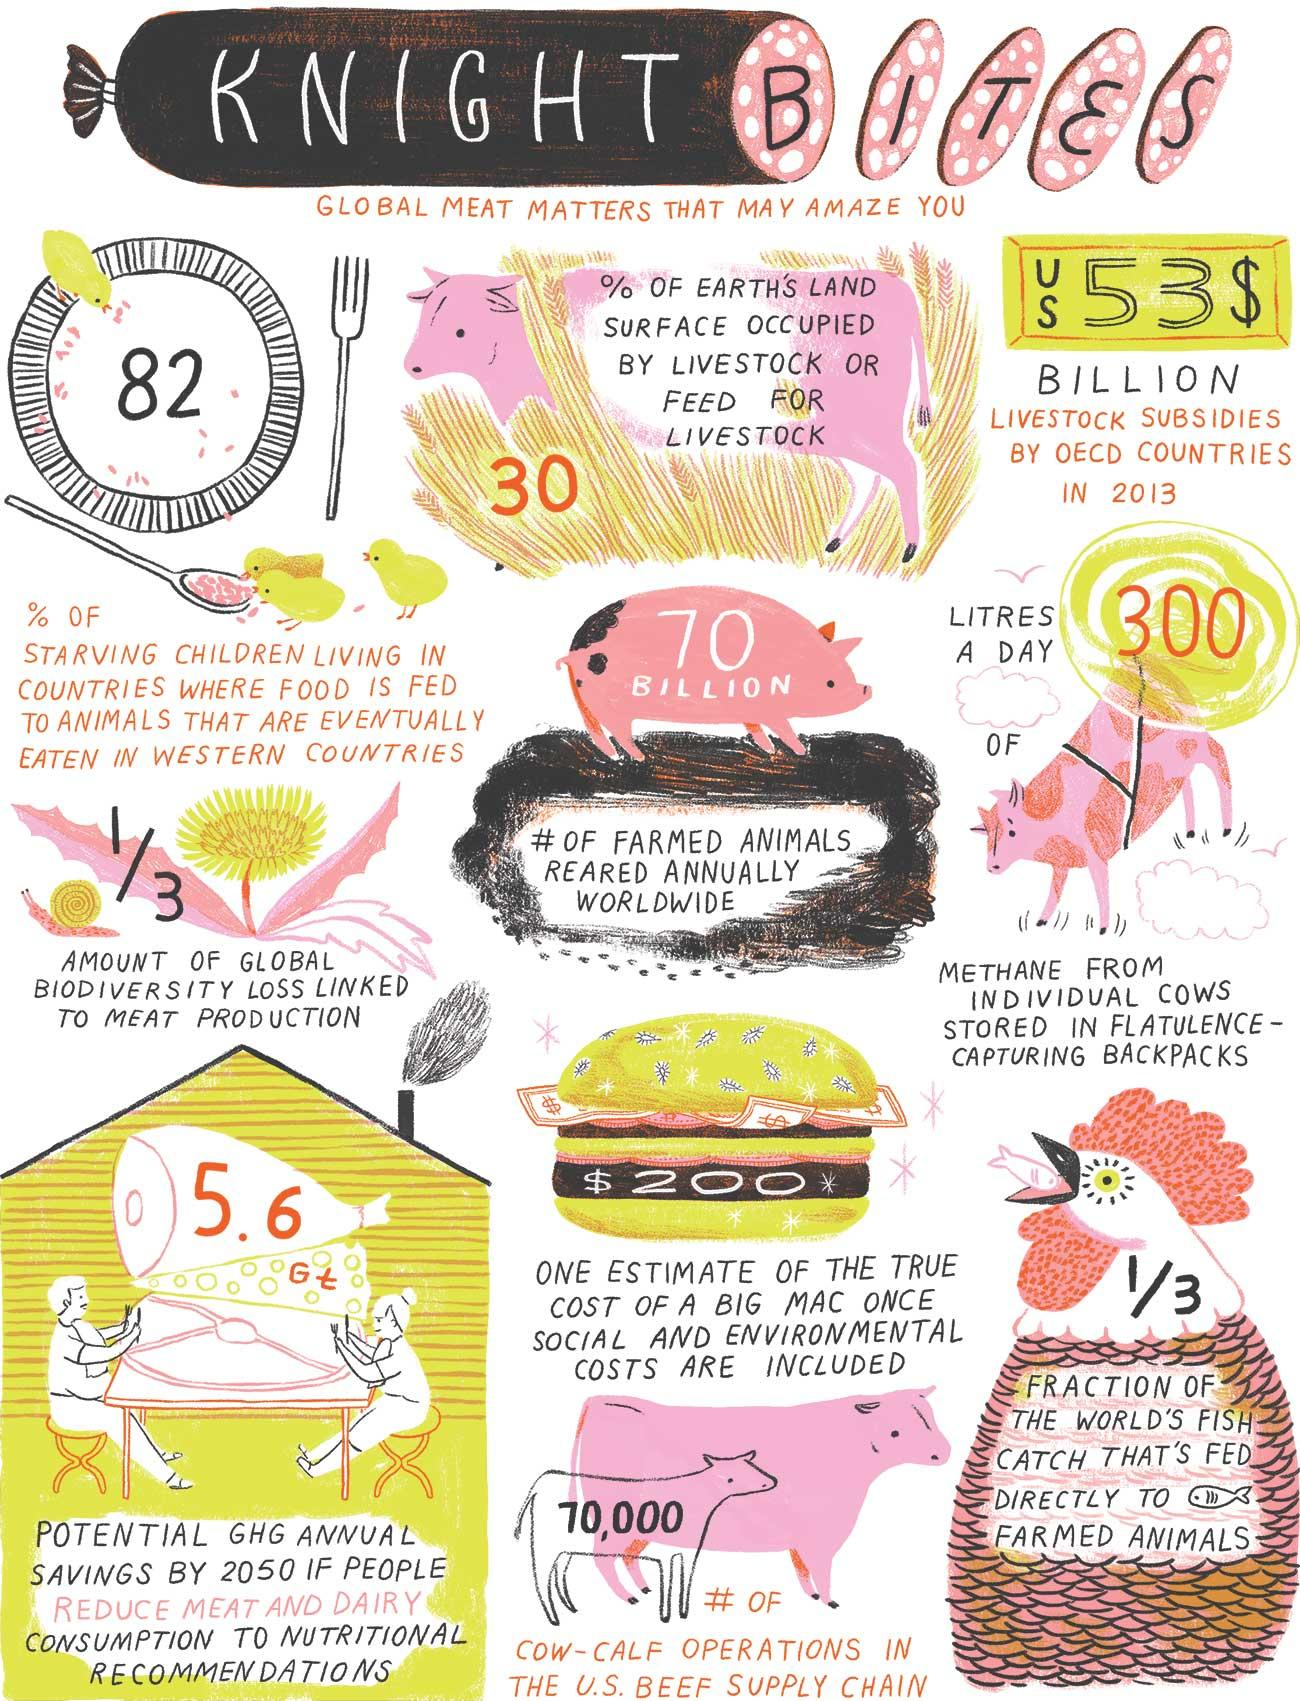Outline some significant characteristics in this image. According to a recent study, 82% of starving children live in countries where food is fed to animals that are eventually consumed in Western countries. This shocking statistic highlights the need for increased efforts to address food insecurity and ensure that everyone has access to adequate nutrition. The number of cow-calf operations in the U.S. beef supply chain is approximately 70,000. Approximately 30% of Earth's land surface is occupied by livestock or feed for livestock. According to estimates, more than 70 BILLION farmed animals are reared annually worldwide. In a day, approximately 300 liters of methane from individual cows is stored in flatulence-capturing backpacks. 